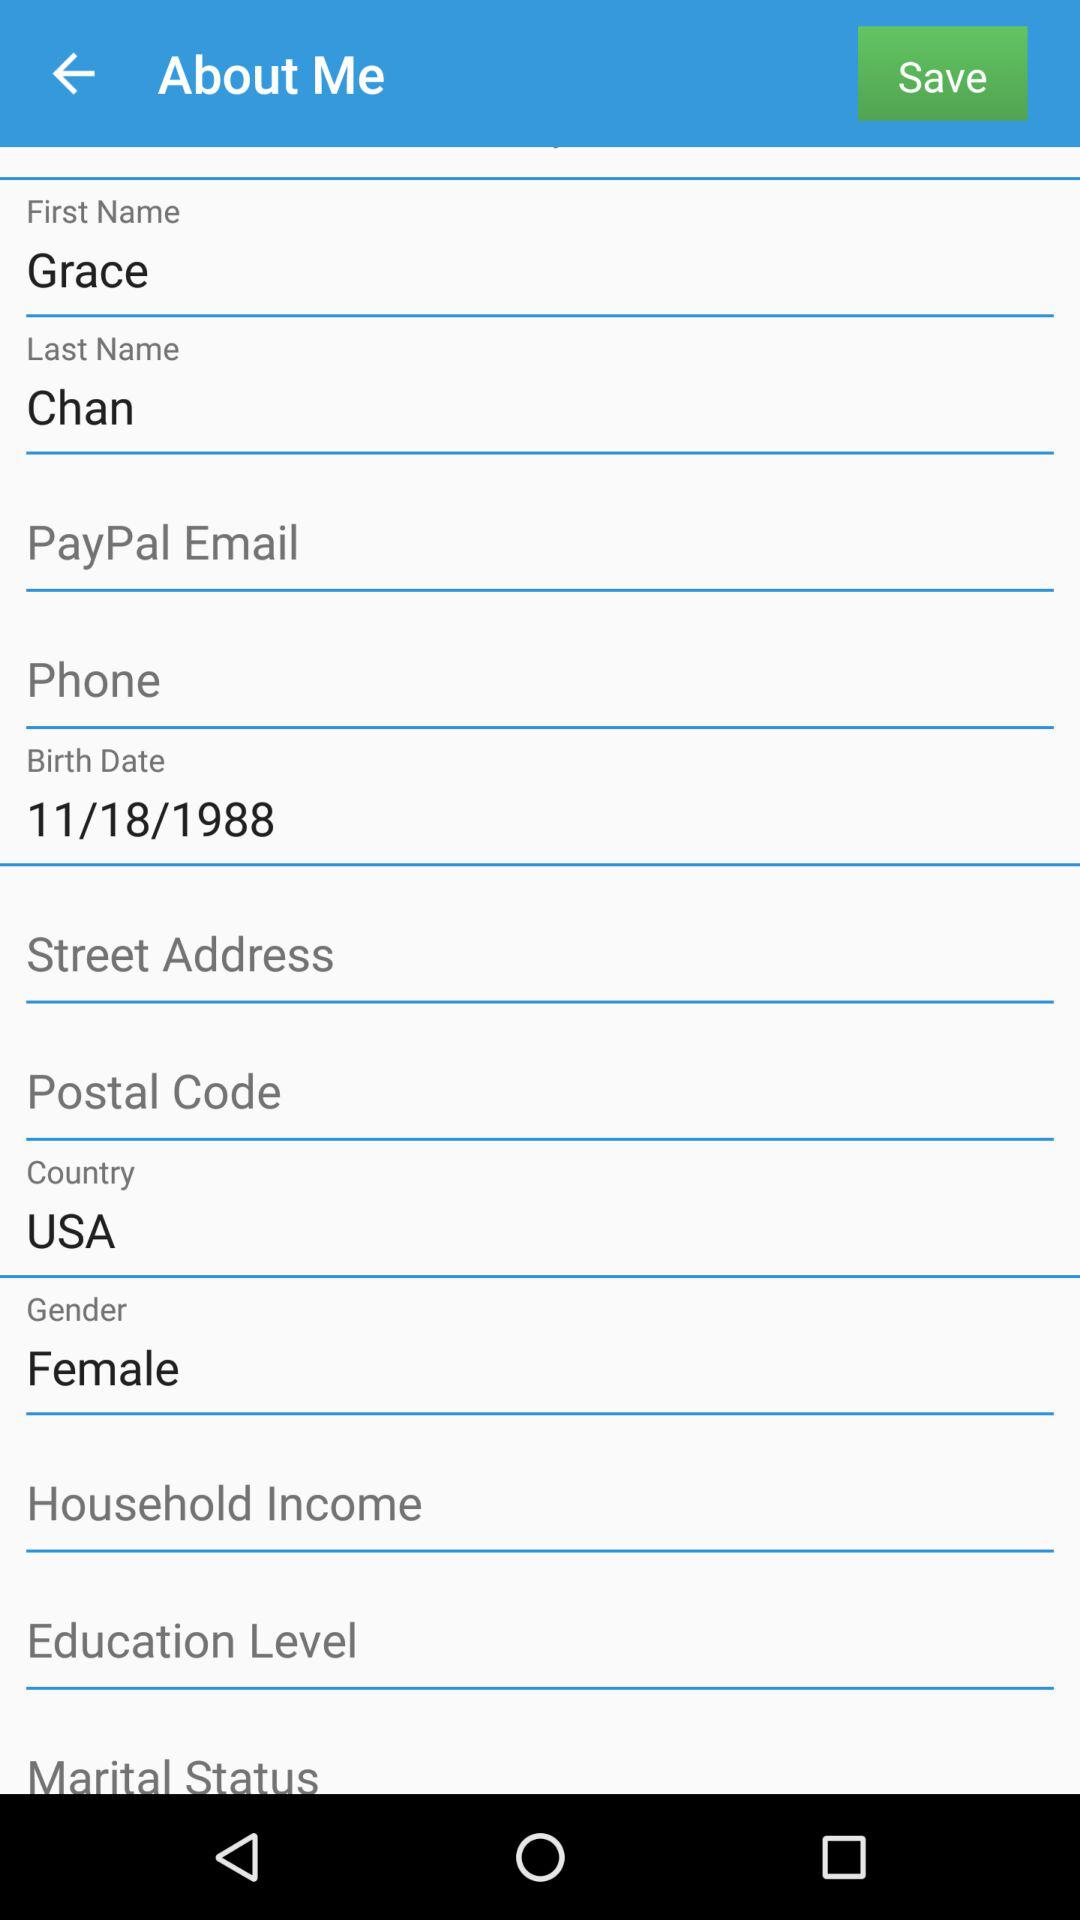What is the date of birth? The date of birth is November 18, 1988. 